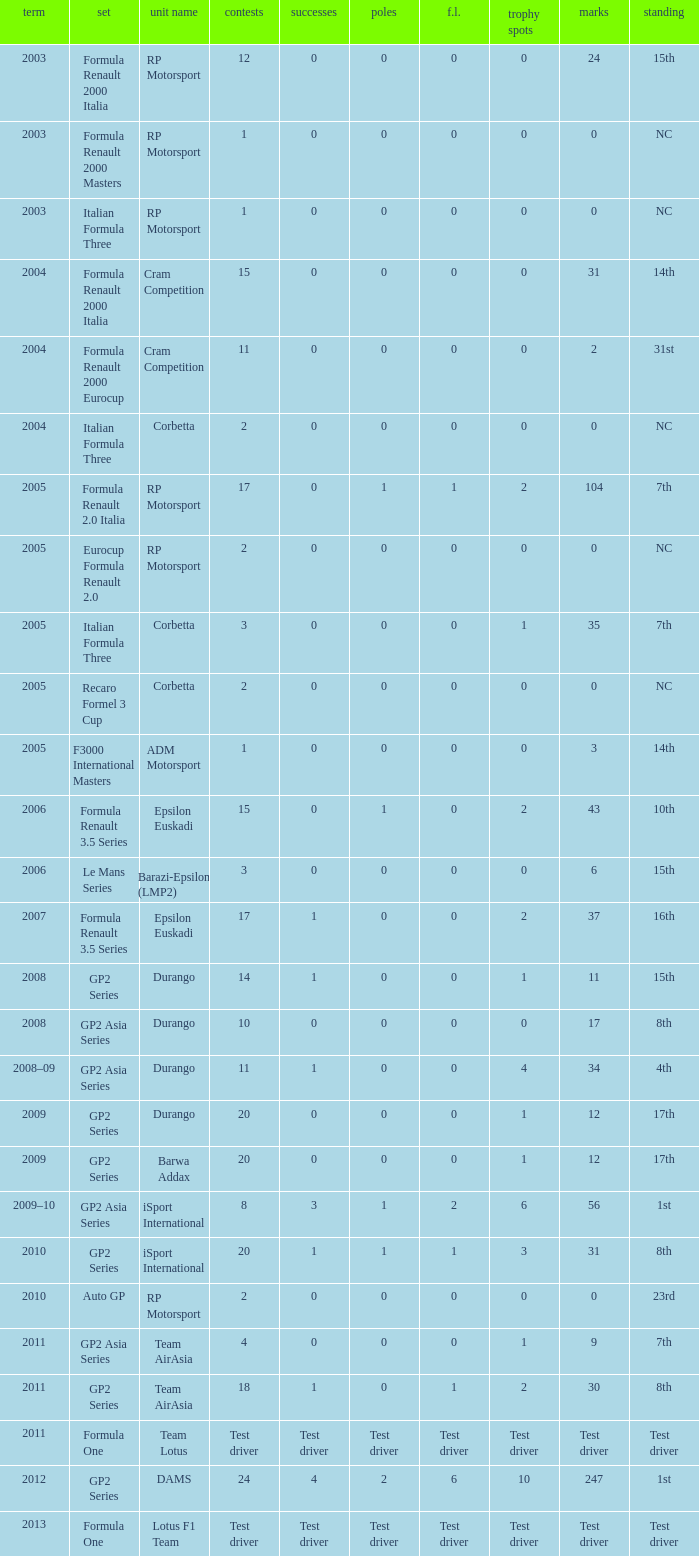What is the number of podiums with 0 wins, 0 F.L. and 35 points? 1.0. 